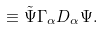Convert formula to latex. <formula><loc_0><loc_0><loc_500><loc_500>\equiv \tilde { \Psi } \Gamma _ { \alpha } D _ { \alpha } \Psi .</formula> 